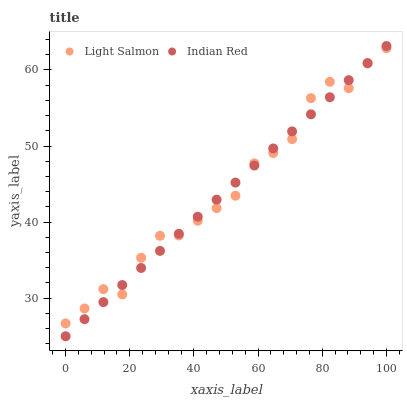Does Indian Red have the minimum area under the curve?
Answer yes or no. Yes. Does Light Salmon have the maximum area under the curve?
Answer yes or no. Yes. Does Indian Red have the maximum area under the curve?
Answer yes or no. No. Is Indian Red the smoothest?
Answer yes or no. Yes. Is Light Salmon the roughest?
Answer yes or no. Yes. Is Indian Red the roughest?
Answer yes or no. No. Does Indian Red have the lowest value?
Answer yes or no. Yes. Does Indian Red have the highest value?
Answer yes or no. Yes. Does Indian Red intersect Light Salmon?
Answer yes or no. Yes. Is Indian Red less than Light Salmon?
Answer yes or no. No. Is Indian Red greater than Light Salmon?
Answer yes or no. No. 